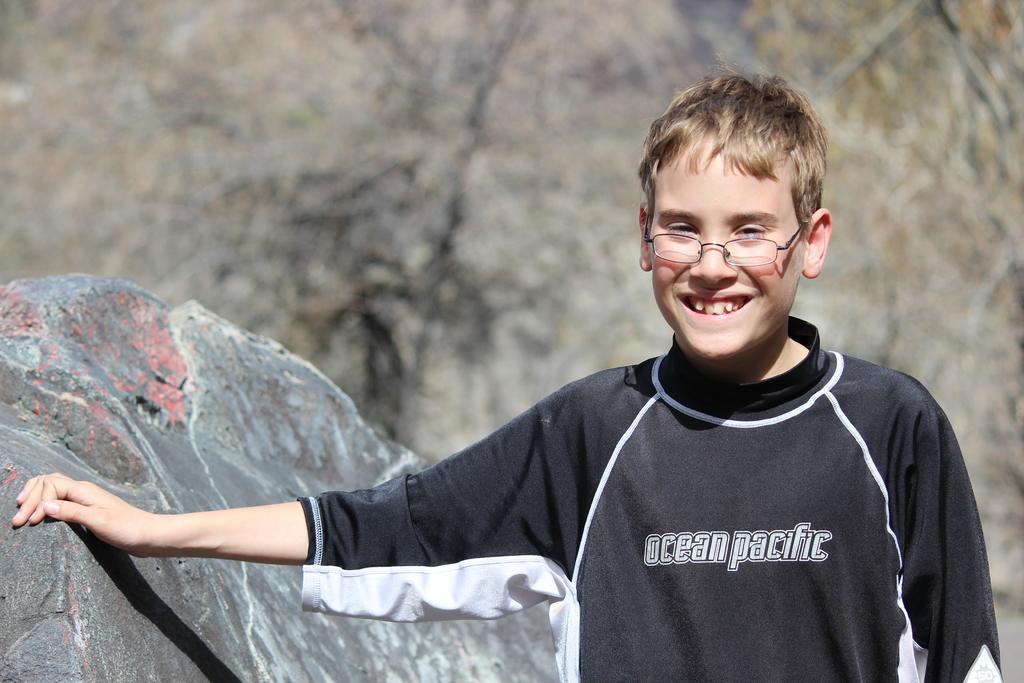Could you give a brief overview of what you see in this image? There is a boy standing and smiling and wore spectacle,beside this boy we can see rock. In the background it is blur. 